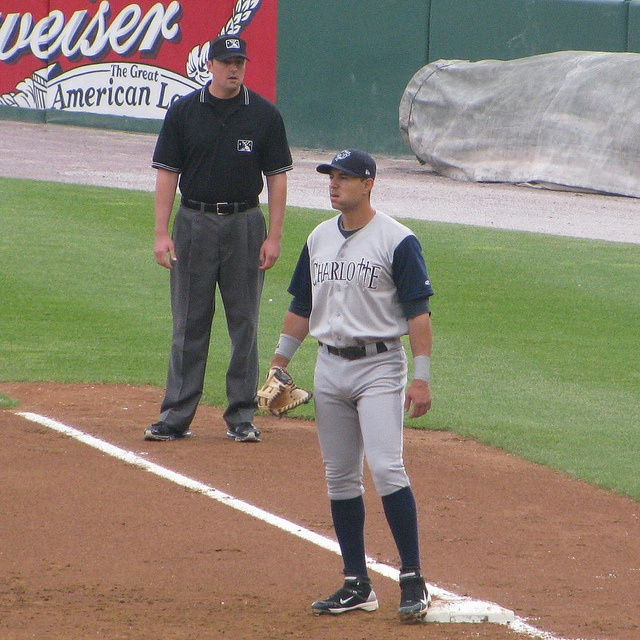Describe the objects in this image and their specific colors. I can see people in brown, darkgray, gray, black, and lightgray tones, people in brown, black, and gray tones, and baseball glove in brown, tan, gray, and maroon tones in this image. 